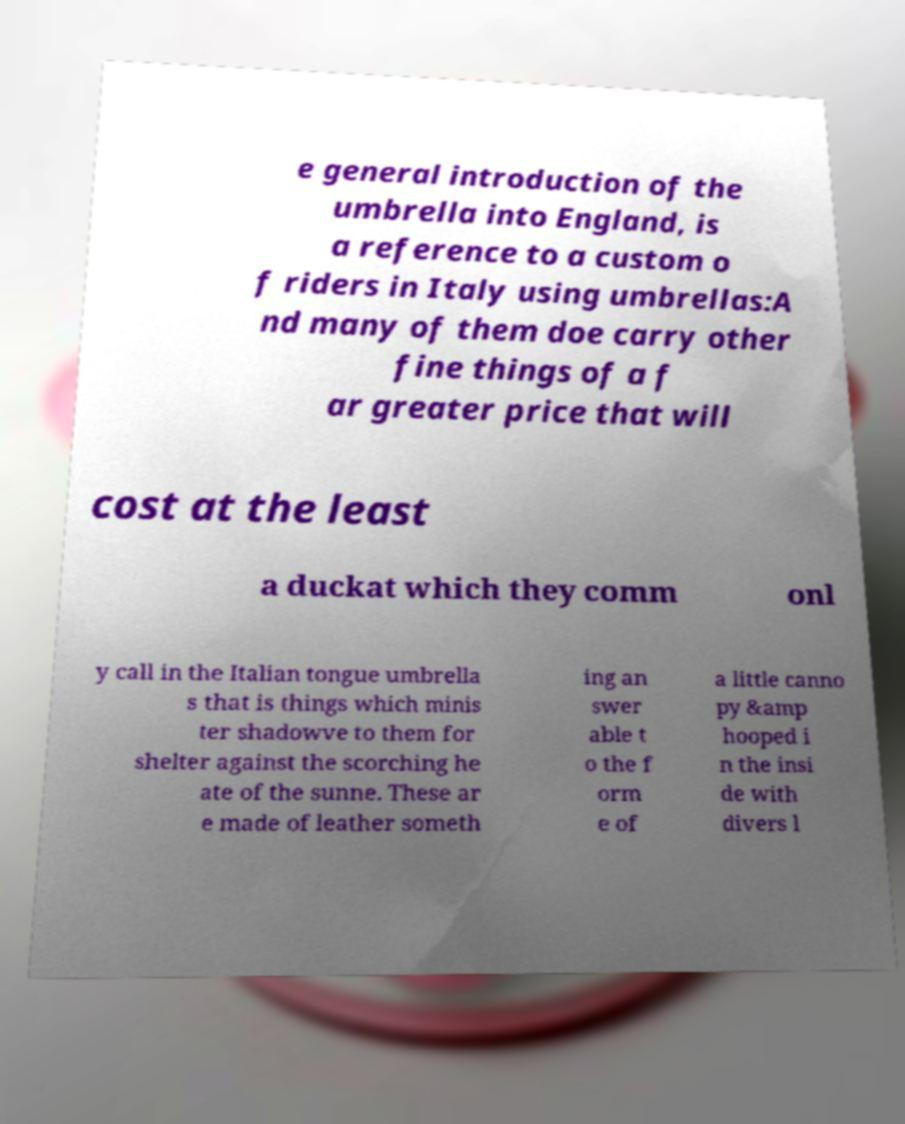Please identify and transcribe the text found in this image. e general introduction of the umbrella into England, is a reference to a custom o f riders in Italy using umbrellas:A nd many of them doe carry other fine things of a f ar greater price that will cost at the least a duckat which they comm onl y call in the Italian tongue umbrella s that is things which minis ter shadowve to them for shelter against the scorching he ate of the sunne. These ar e made of leather someth ing an swer able t o the f orm e of a little canno py &amp hooped i n the insi de with divers l 